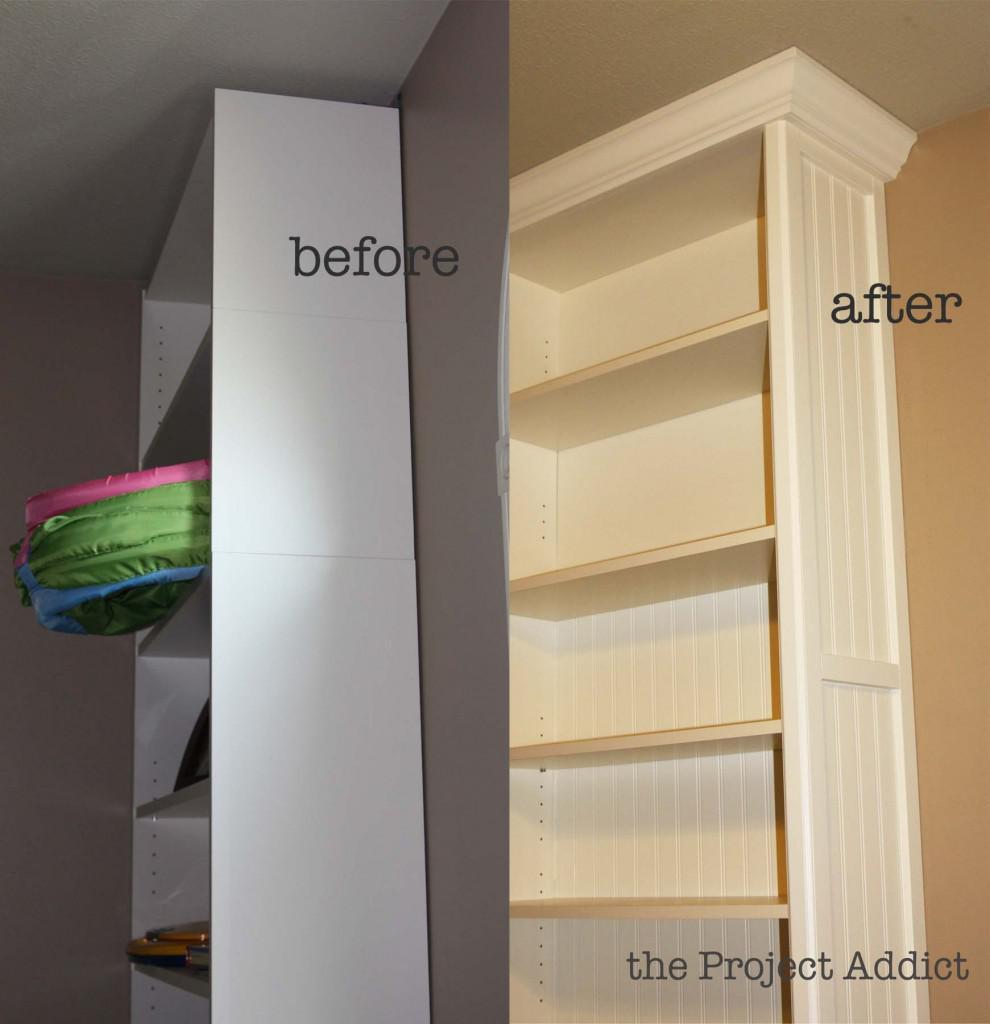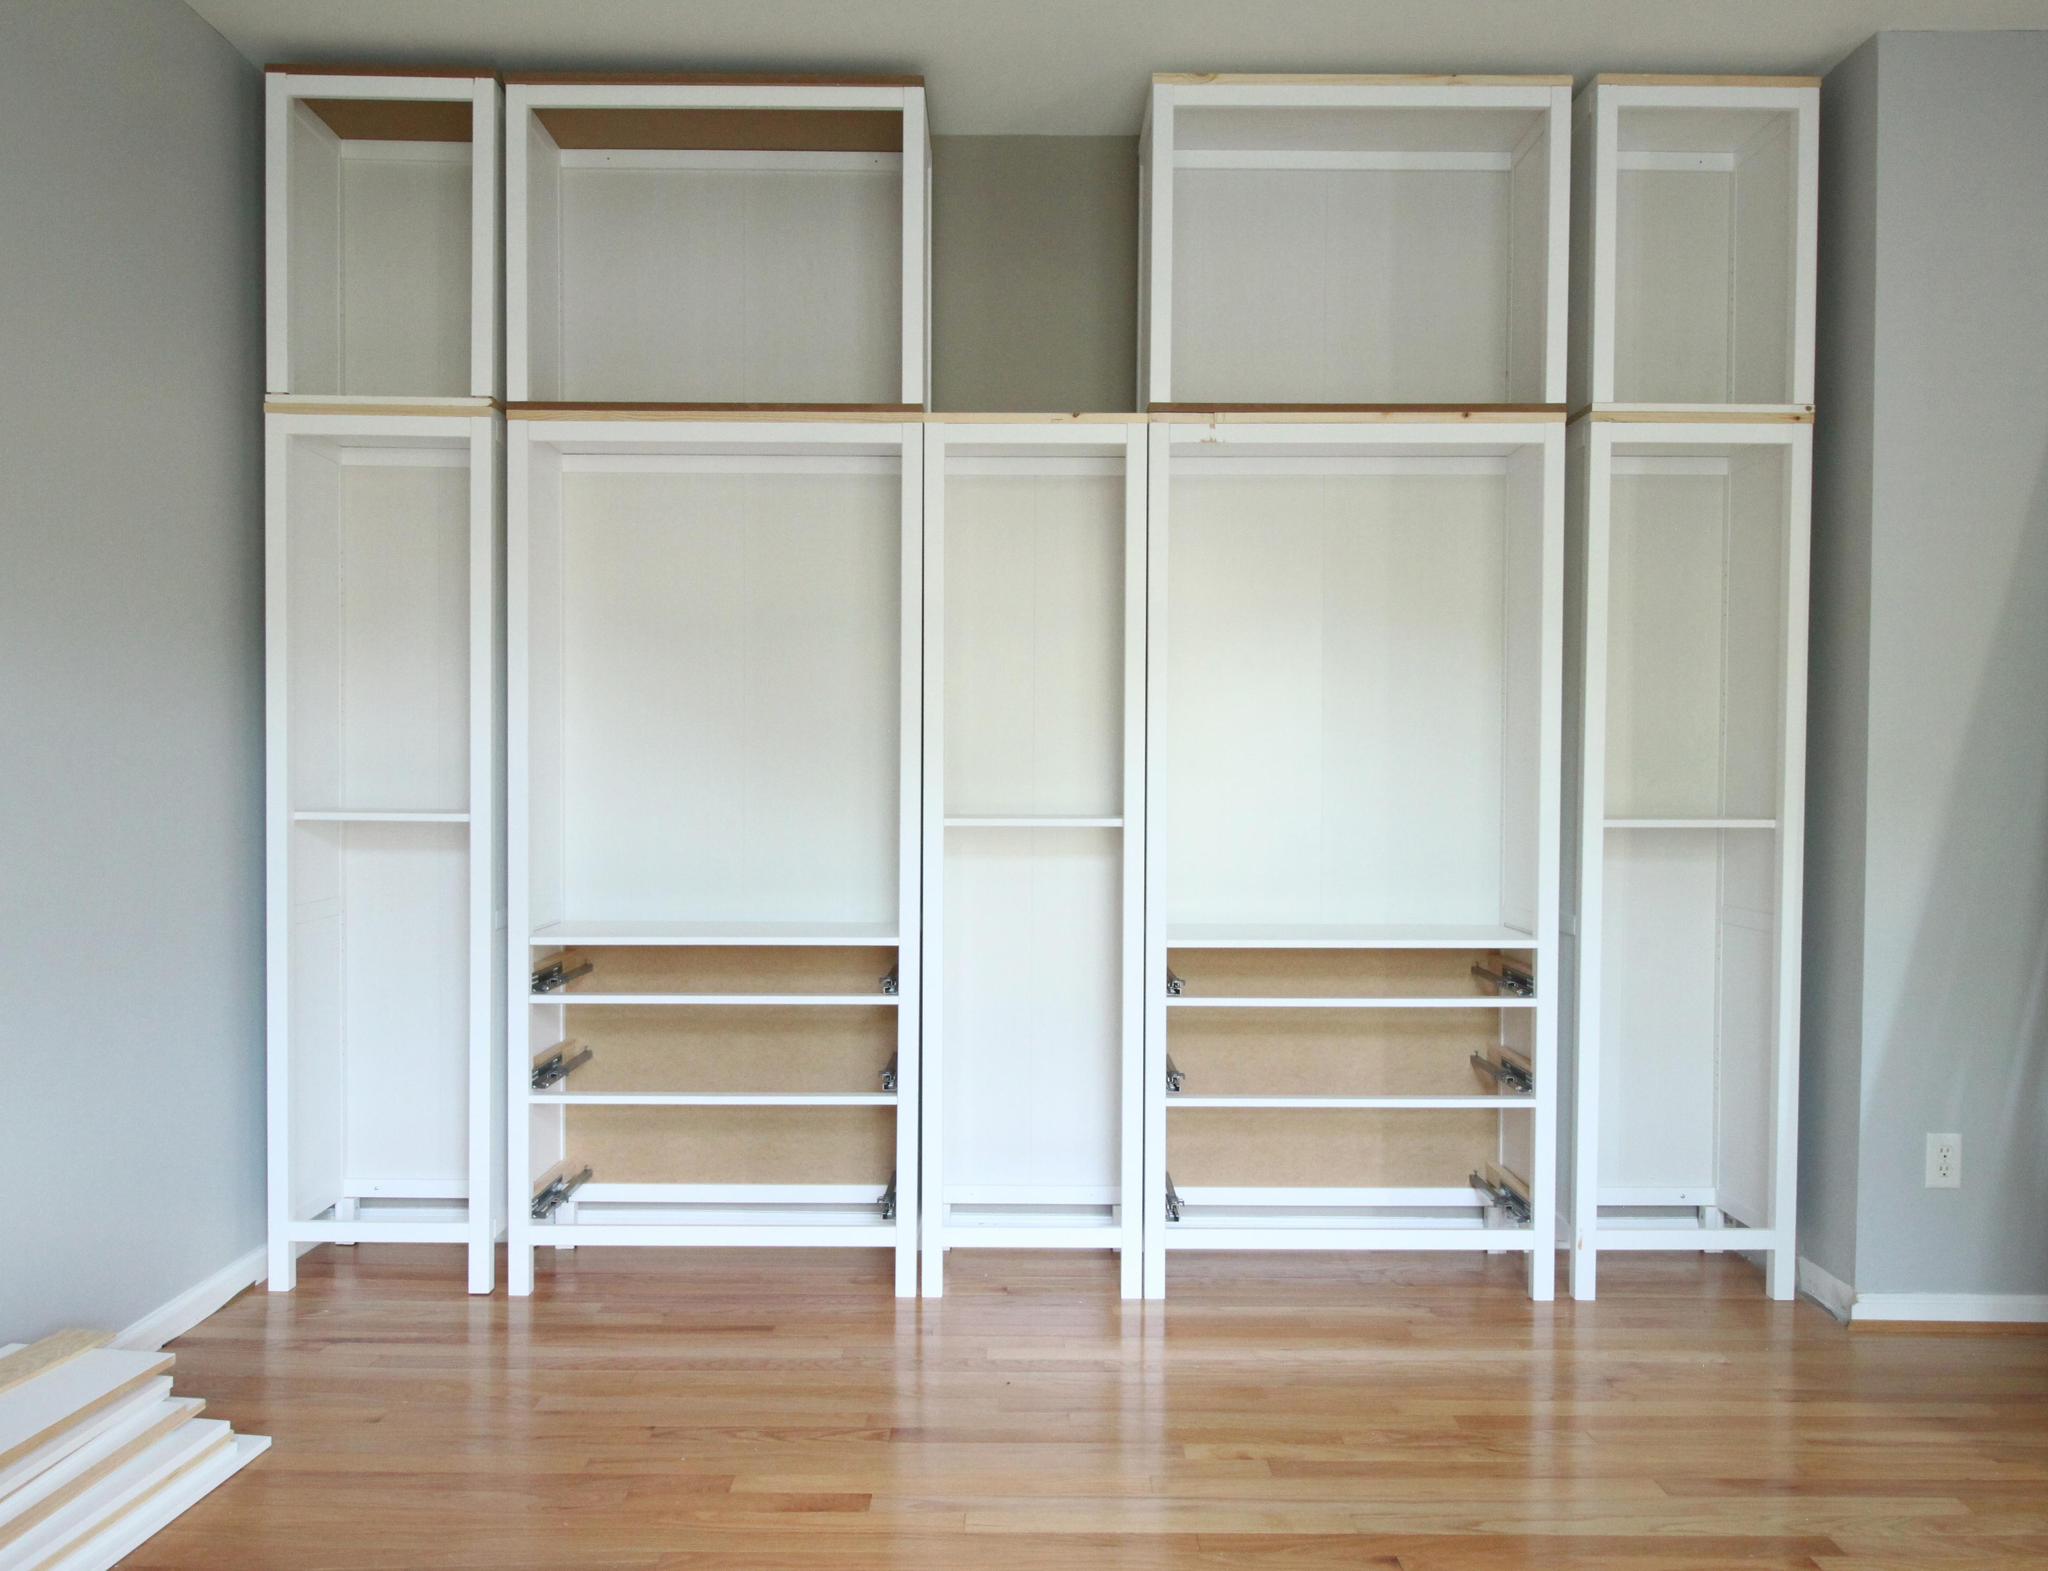The first image is the image on the left, the second image is the image on the right. Examine the images to the left and right. Is the description "Each image includes an empty white storage unit that reaches toward the ceiling, and at least one image shows a storage unit on a light wood floor." accurate? Answer yes or no. Yes. The first image is the image on the left, the second image is the image on the right. Assess this claim about the two images: "The shelving unit in the image on the right is empty.". Correct or not? Answer yes or no. Yes. 